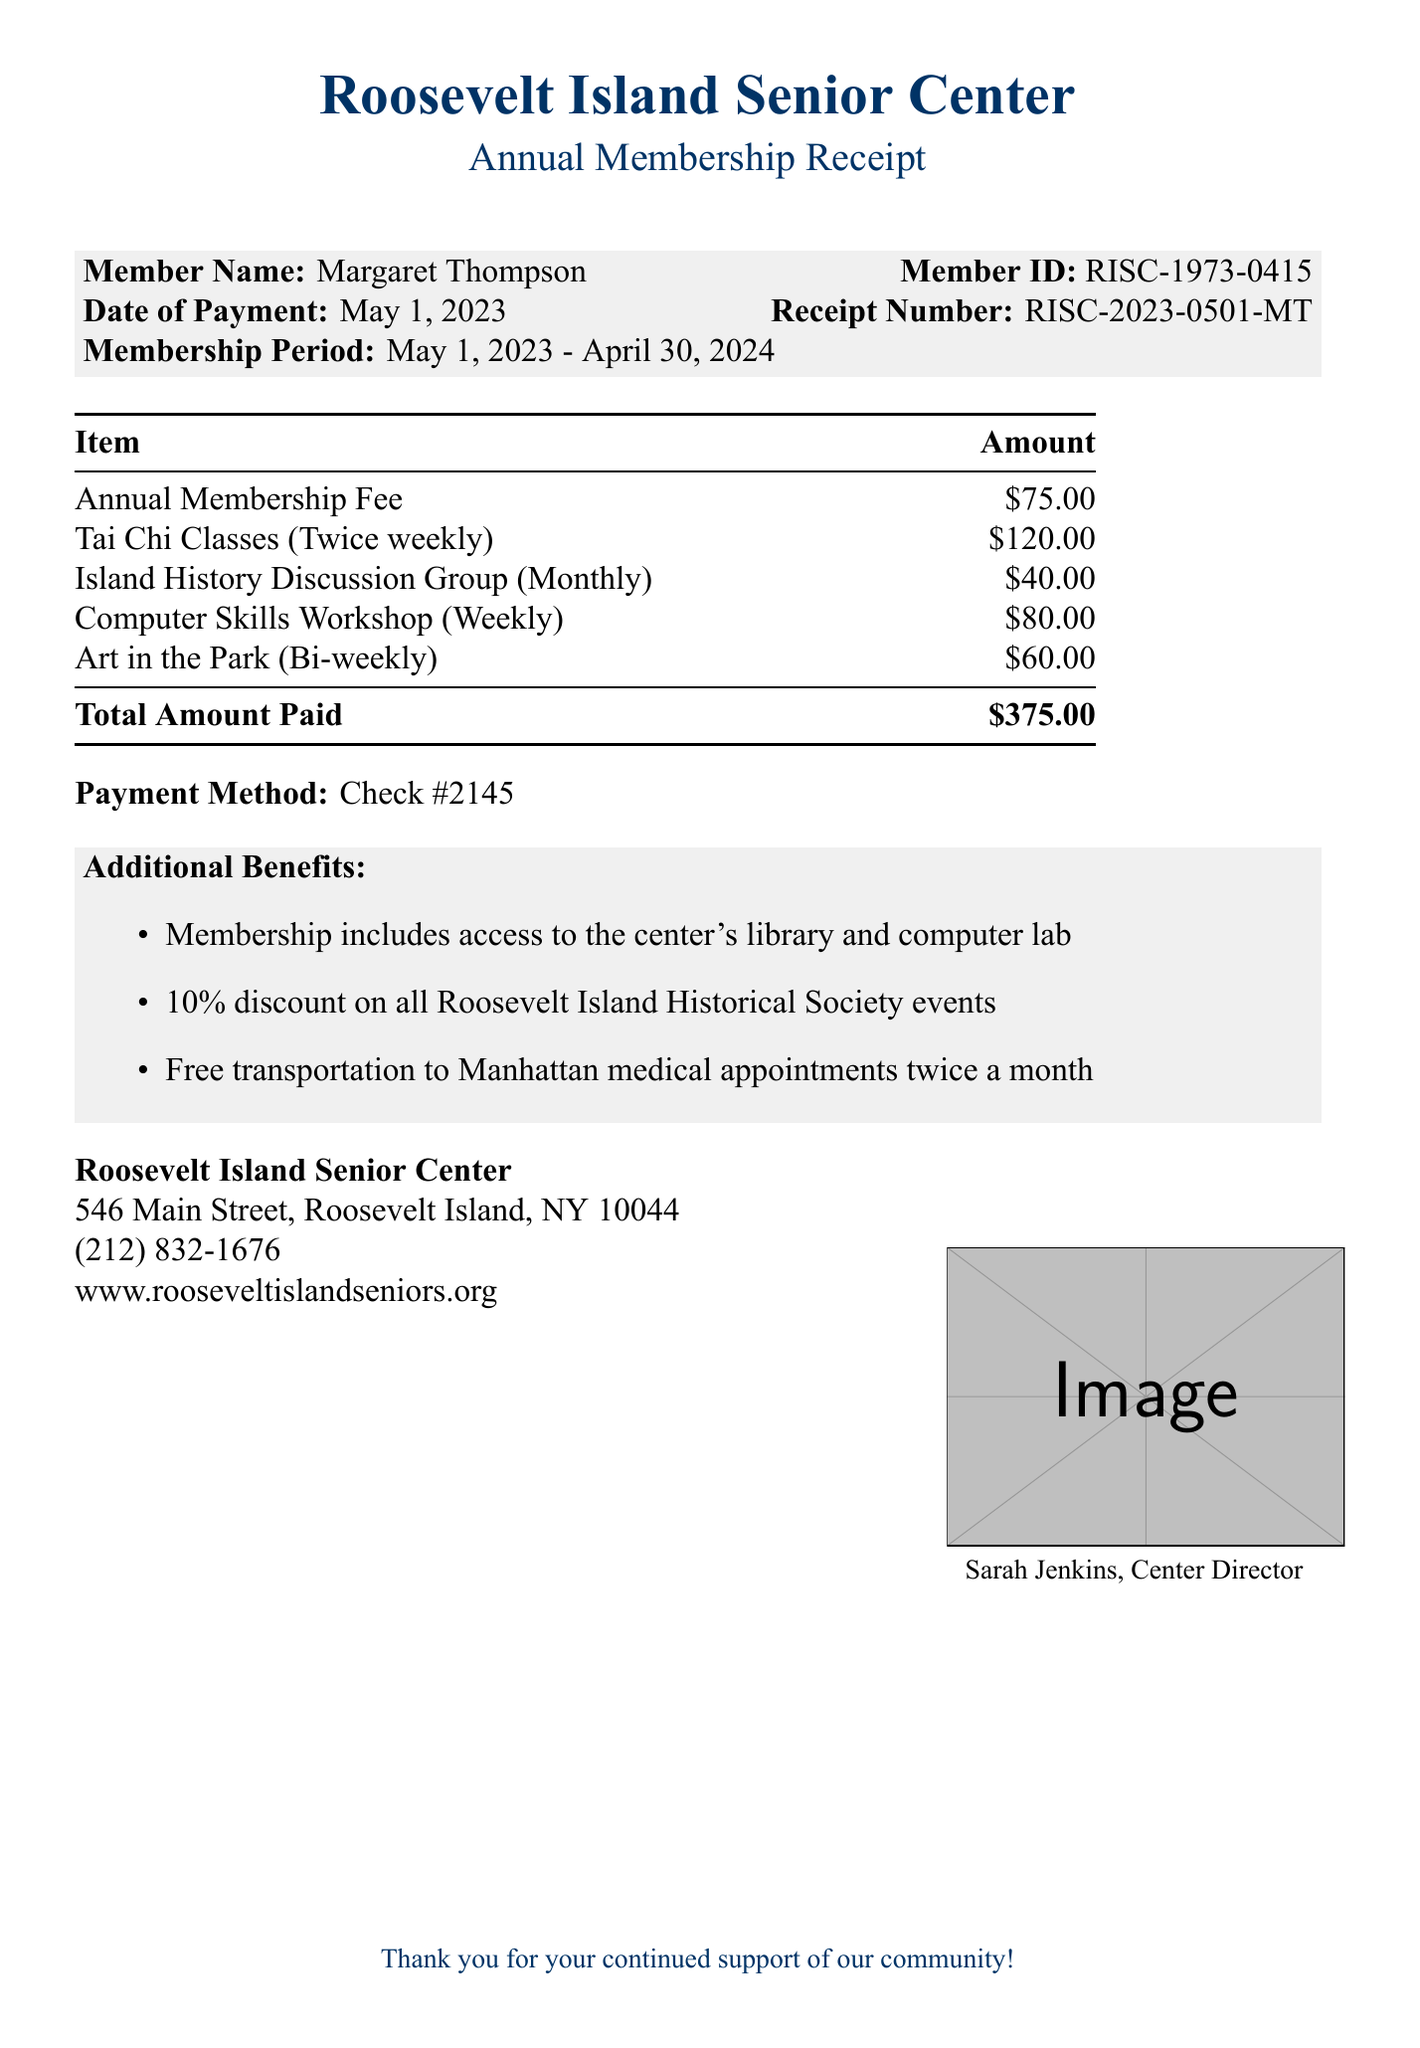What is the name of the member? The document states the member's name as Margaret Thompson.
Answer: Margaret Thompson What is the member ID? The document specifies the member ID as RISC-1973-0415.
Answer: RISC-1973-0415 When was the payment made? The date of payment provided in the document is May 1, 2023.
Answer: May 1, 2023 What is the total amount paid? The total amount paid listed in the document is $375.00.
Answer: $375.00 What is the annual fee for the Computer Skills Workshop? The document mentions that the annual fee for the Computer Skills Workshop is $80.00.
Answer: $80.00 How long is the membership period? The membership period is specified in the document as May 1, 2023 - April 30, 2024.
Answer: May 1, 2023 - April 30, 2024 How many activity fees are listed in the document? The document provides a list of four activity fees related to different programs.
Answer: Four What is one of the additional benefits of membership? The document lists several additional benefits, one of which is access to the center's library.
Answer: Access to the center's library Who authorized the payment receipt? The document states that the receipt was authorized by Sarah Jenkins.
Answer: Sarah Jenkins What payment method was used? The document specifies that the payment method used was Check #2145.
Answer: Check #2145 